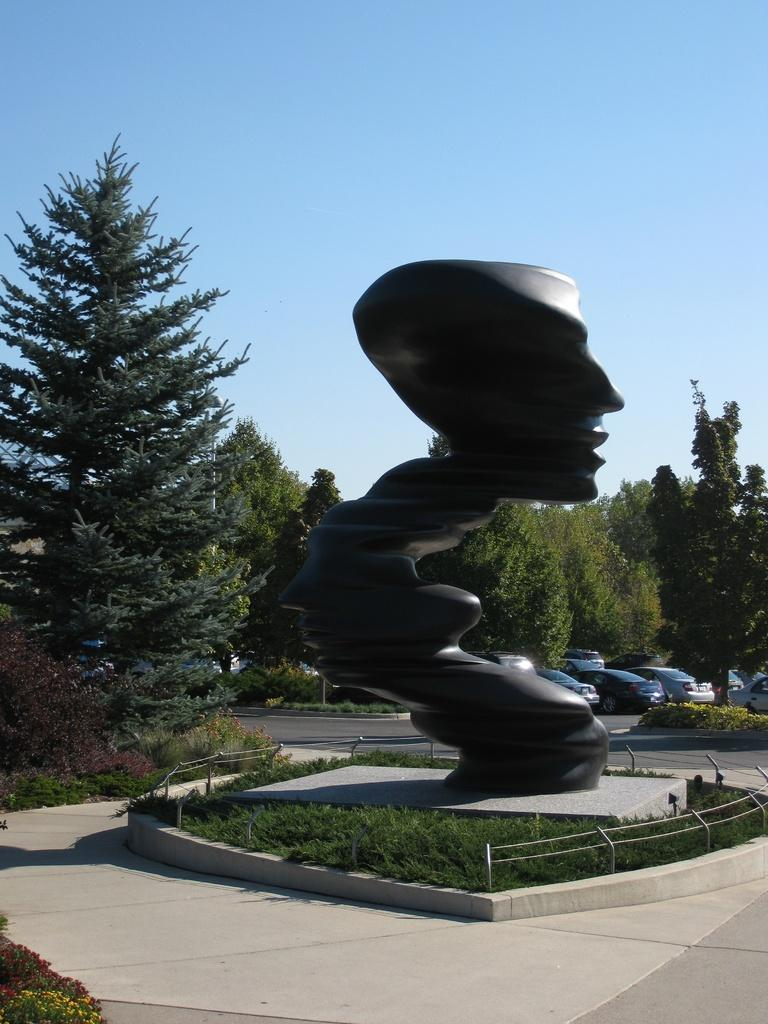What is the main subject in the image? There is a statue in the image. What is the color of the statue? The statue is black in color. What surrounds the statue in the image? There is a fence around the statue. What can be seen in the background of the image? There are trees and vehicles in the background of the image. What type of word is written on the statue in the image? There are no words written on the statue in the image. Can you see any farm animals in the image? There are no farm animals present in the image. 